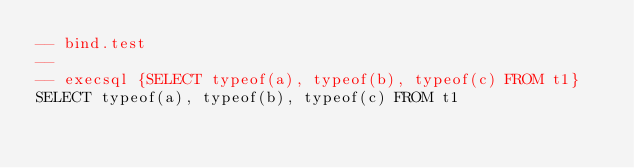<code> <loc_0><loc_0><loc_500><loc_500><_SQL_>-- bind.test
-- 
-- execsql {SELECT typeof(a), typeof(b), typeof(c) FROM t1}
SELECT typeof(a), typeof(b), typeof(c) FROM t1</code> 